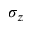Convert formula to latex. <formula><loc_0><loc_0><loc_500><loc_500>\sigma _ { z }</formula> 